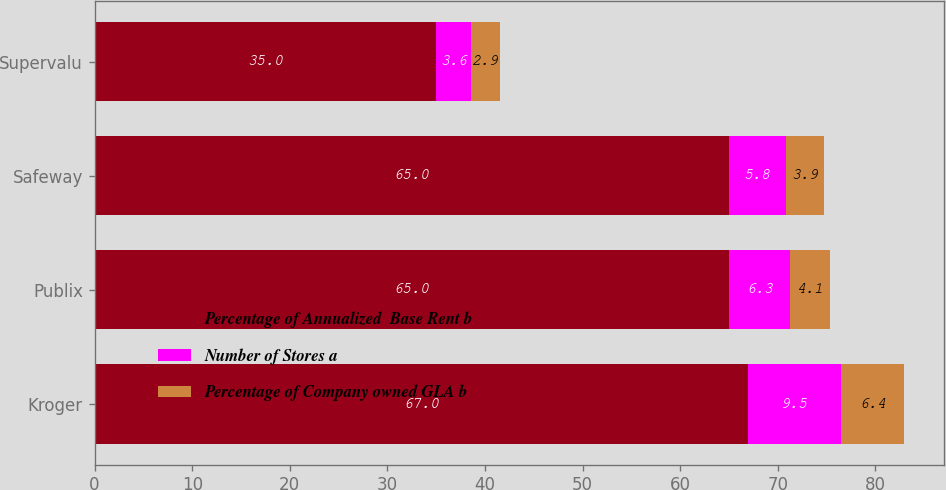<chart> <loc_0><loc_0><loc_500><loc_500><stacked_bar_chart><ecel><fcel>Kroger<fcel>Publix<fcel>Safeway<fcel>Supervalu<nl><fcel>Percentage of Annualized  Base Rent b<fcel>67<fcel>65<fcel>65<fcel>35<nl><fcel>Number of Stores a<fcel>9.5<fcel>6.3<fcel>5.8<fcel>3.6<nl><fcel>Percentage of Company owned GLA b<fcel>6.4<fcel>4.1<fcel>3.9<fcel>2.9<nl></chart> 